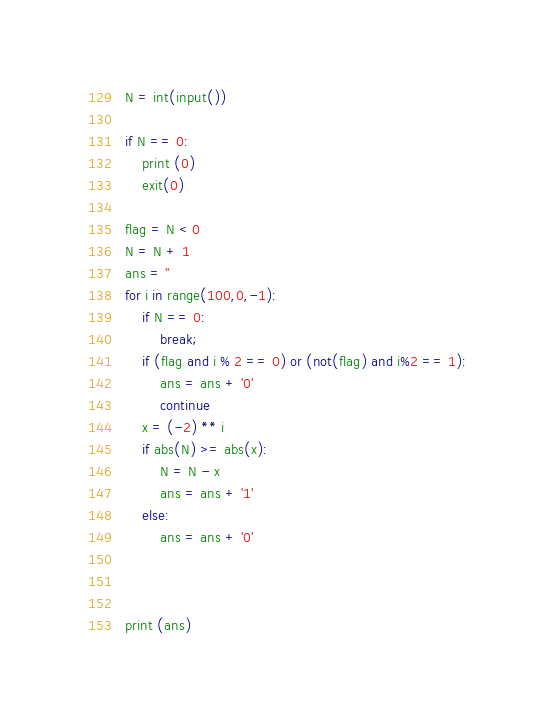Convert code to text. <code><loc_0><loc_0><loc_500><loc_500><_Python_>N = int(input())

if N == 0:
    print (0)
    exit(0)

flag = N < 0
N = N + 1
ans = ''
for i in range(100,0,-1):
    if N == 0:
        break;
    if (flag and i % 2 == 0) or (not(flag) and i%2 == 1):
        ans = ans + '0'
        continue
    x = (-2) ** i
    if abs(N) >= abs(x):
        N = N - x
        ans = ans + '1'
    else:
        ans = ans + '0'
    


print (ans)
</code> 